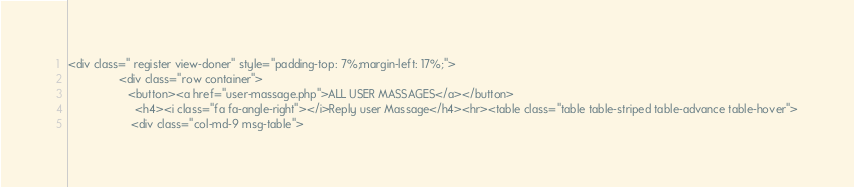<code> <loc_0><loc_0><loc_500><loc_500><_PHP_><div class=" register view-doner" style="padding-top: 7%;margin-left: 17%;">
                <div class="row container">
                   <button><a href="user-massage.php">ALL USER MASSAGES</a></button>
                     <h4><i class="fa fa-angle-right"></i>Reply user Massage</h4><hr><table class="table table-striped table-advance table-hover">
                    <div class="col-md-9 msg-table">
</code> 